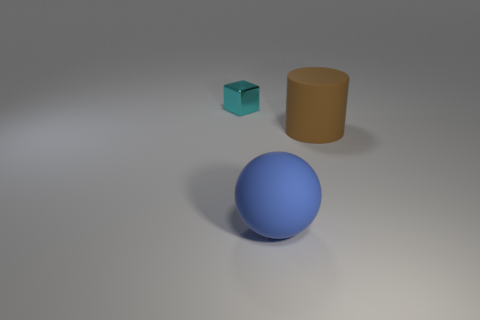Add 1 cyan matte things. How many objects exist? 4 Subtract all spheres. How many objects are left? 2 Subtract all green rubber spheres. Subtract all shiny cubes. How many objects are left? 2 Add 2 big blue matte objects. How many big blue matte objects are left? 3 Add 2 cyan blocks. How many cyan blocks exist? 3 Subtract 0 cyan balls. How many objects are left? 3 